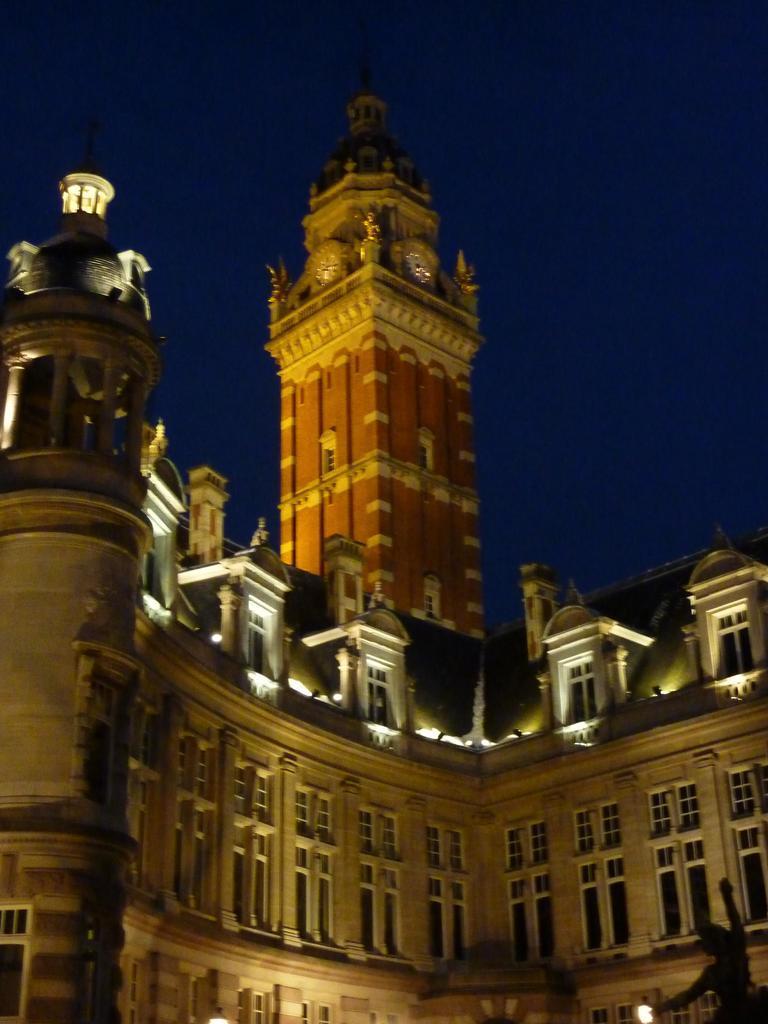Could you give a brief overview of what you see in this image? In this image in the front there is a statue. In the center there is a building. In the background there is a tower. 